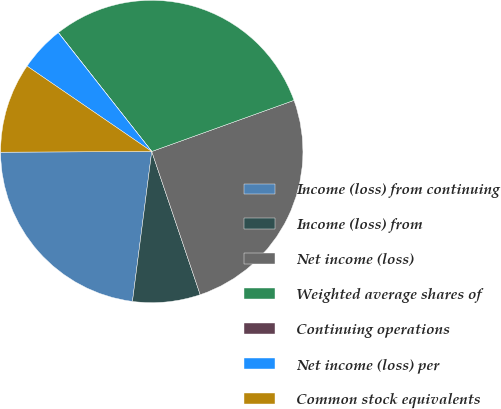Convert chart. <chart><loc_0><loc_0><loc_500><loc_500><pie_chart><fcel>Income (loss) from continuing<fcel>Income (loss) from<fcel>Net income (loss)<fcel>Weighted average shares of<fcel>Continuing operations<fcel>Net income (loss) per<fcel>Common stock equivalents<nl><fcel>22.89%<fcel>7.23%<fcel>25.3%<fcel>30.1%<fcel>0.02%<fcel>4.83%<fcel>9.63%<nl></chart> 